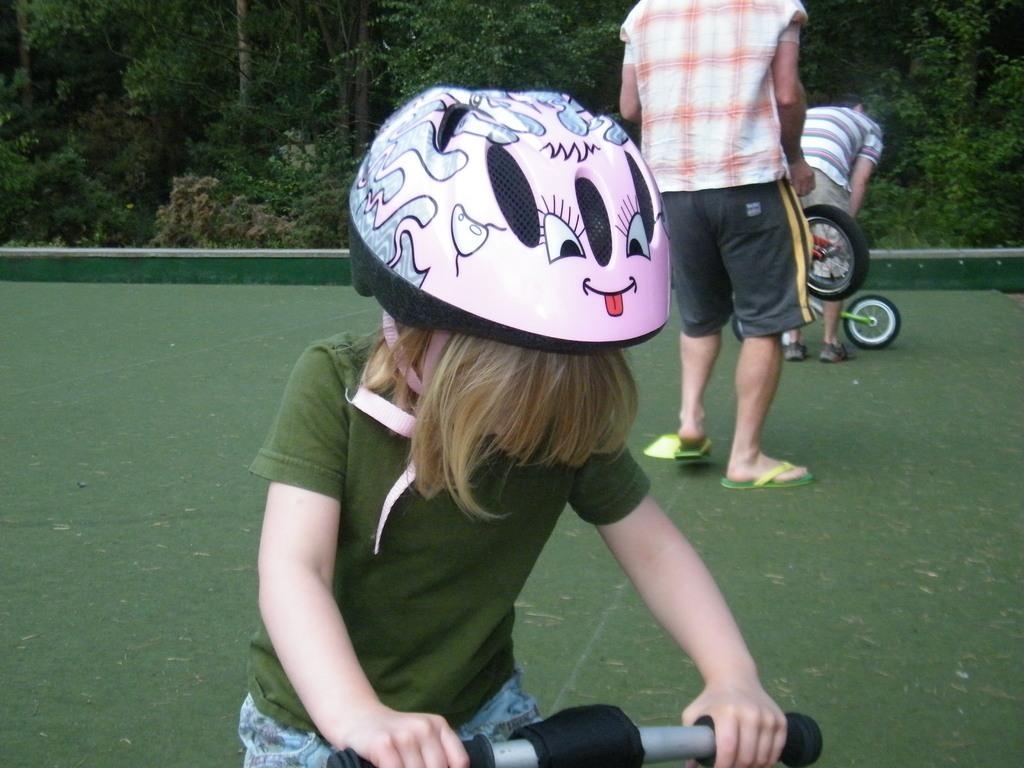What is the child holding in the image? The child is holding a bicycle. What type of protective gear is the child wearing? The child is wearing a pink helmet. What color is the child's t-shirt? The child is wearing a green t-shirt. What type of pants is the child wearing? The child is wearing jeans. What can be seen in the background of the image? There are other people and trees in the background. Can you hear the child whistling in the image? There is no indication of sound in the image, so it cannot be determined if the child is whistling or not. 